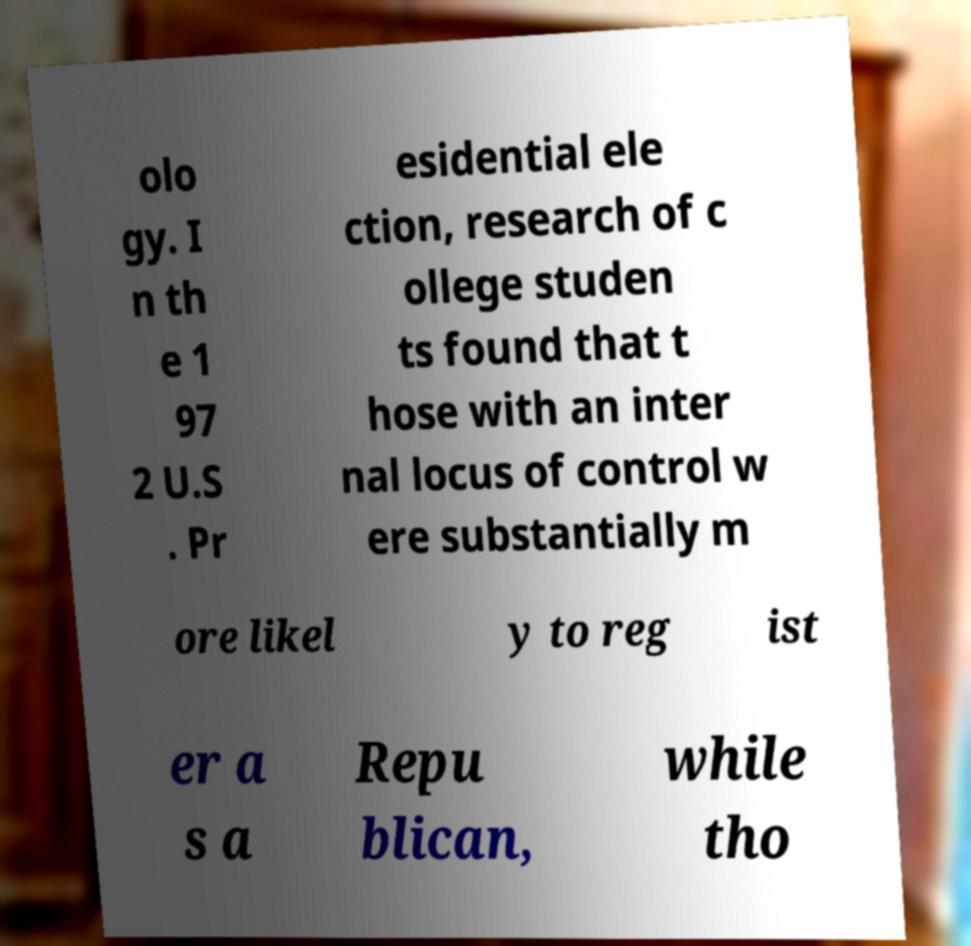Can you accurately transcribe the text from the provided image for me? olo gy. I n th e 1 97 2 U.S . Pr esidential ele ction, research of c ollege studen ts found that t hose with an inter nal locus of control w ere substantially m ore likel y to reg ist er a s a Repu blican, while tho 